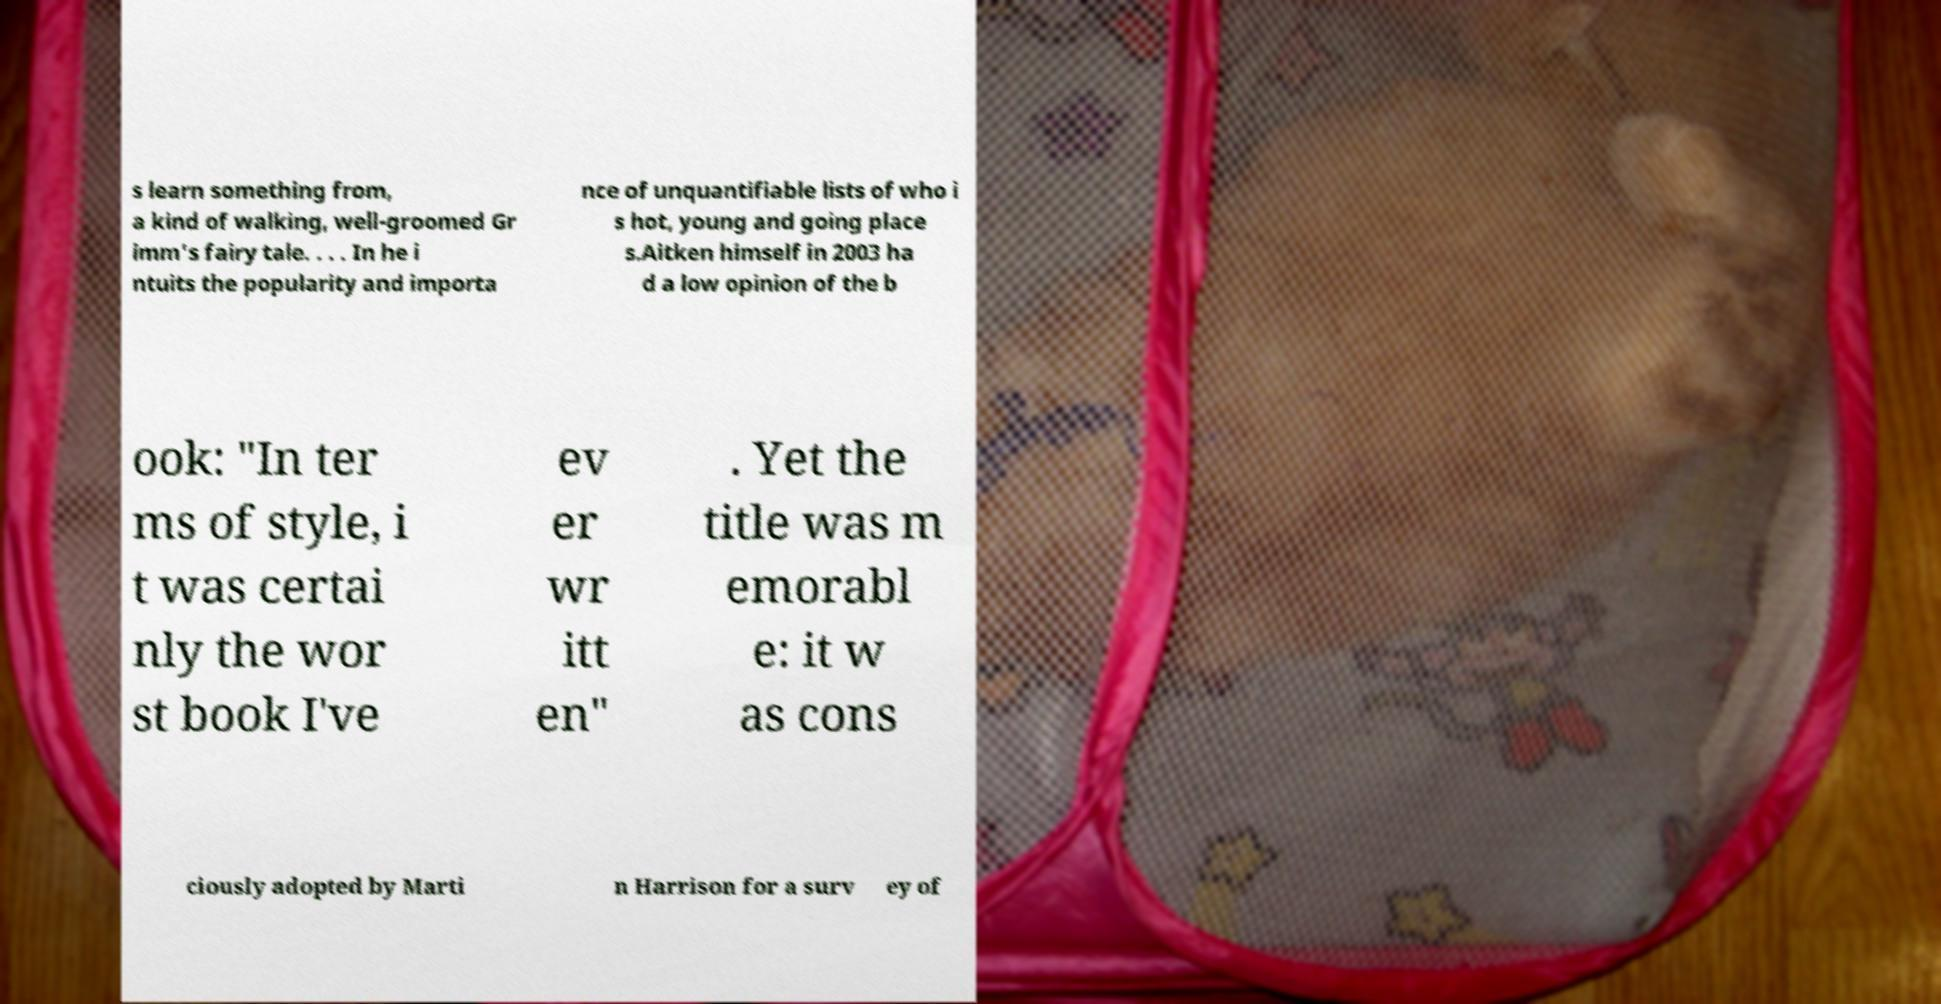Please read and relay the text visible in this image. What does it say? s learn something from, a kind of walking, well-groomed Gr imm's fairy tale. . . . In he i ntuits the popularity and importa nce of unquantifiable lists of who i s hot, young and going place s.Aitken himself in 2003 ha d a low opinion of the b ook: "In ter ms of style, i t was certai nly the wor st book I've ev er wr itt en" . Yet the title was m emorabl e: it w as cons ciously adopted by Marti n Harrison for a surv ey of 